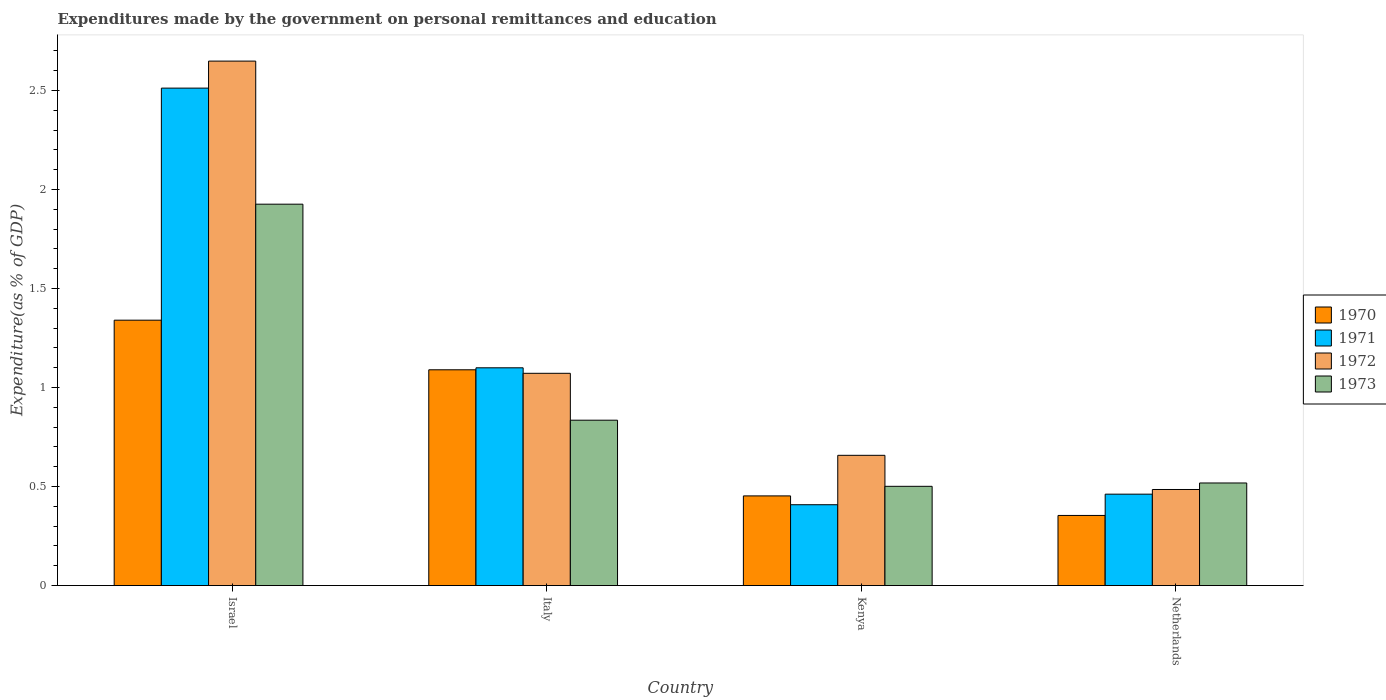How many groups of bars are there?
Make the answer very short. 4. Are the number of bars per tick equal to the number of legend labels?
Your answer should be very brief. Yes. Are the number of bars on each tick of the X-axis equal?
Give a very brief answer. Yes. How many bars are there on the 4th tick from the left?
Ensure brevity in your answer.  4. How many bars are there on the 1st tick from the right?
Make the answer very short. 4. What is the expenditures made by the government on personal remittances and education in 1973 in Netherlands?
Ensure brevity in your answer.  0.52. Across all countries, what is the maximum expenditures made by the government on personal remittances and education in 1973?
Give a very brief answer. 1.93. Across all countries, what is the minimum expenditures made by the government on personal remittances and education in 1970?
Your answer should be compact. 0.35. In which country was the expenditures made by the government on personal remittances and education in 1970 maximum?
Make the answer very short. Israel. What is the total expenditures made by the government on personal remittances and education in 1970 in the graph?
Offer a very short reply. 3.24. What is the difference between the expenditures made by the government on personal remittances and education in 1970 in Israel and that in Kenya?
Your response must be concise. 0.89. What is the difference between the expenditures made by the government on personal remittances and education in 1972 in Israel and the expenditures made by the government on personal remittances and education in 1971 in Netherlands?
Your response must be concise. 2.19. What is the average expenditures made by the government on personal remittances and education in 1971 per country?
Provide a succinct answer. 1.12. What is the difference between the expenditures made by the government on personal remittances and education of/in 1971 and expenditures made by the government on personal remittances and education of/in 1973 in Netherlands?
Provide a short and direct response. -0.06. What is the ratio of the expenditures made by the government on personal remittances and education in 1970 in Italy to that in Kenya?
Your response must be concise. 2.41. What is the difference between the highest and the second highest expenditures made by the government on personal remittances and education in 1972?
Provide a short and direct response. -0.41. What is the difference between the highest and the lowest expenditures made by the government on personal remittances and education in 1973?
Keep it short and to the point. 1.42. In how many countries, is the expenditures made by the government on personal remittances and education in 1970 greater than the average expenditures made by the government on personal remittances and education in 1970 taken over all countries?
Provide a succinct answer. 2. What does the 2nd bar from the left in Israel represents?
Offer a very short reply. 1971. What does the 1st bar from the right in Kenya represents?
Your answer should be compact. 1973. How many bars are there?
Offer a terse response. 16. How many legend labels are there?
Offer a terse response. 4. How are the legend labels stacked?
Provide a short and direct response. Vertical. What is the title of the graph?
Your response must be concise. Expenditures made by the government on personal remittances and education. What is the label or title of the Y-axis?
Keep it short and to the point. Expenditure(as % of GDP). What is the Expenditure(as % of GDP) in 1970 in Israel?
Offer a terse response. 1.34. What is the Expenditure(as % of GDP) of 1971 in Israel?
Your answer should be compact. 2.51. What is the Expenditure(as % of GDP) in 1972 in Israel?
Make the answer very short. 2.65. What is the Expenditure(as % of GDP) in 1973 in Israel?
Provide a succinct answer. 1.93. What is the Expenditure(as % of GDP) in 1970 in Italy?
Your response must be concise. 1.09. What is the Expenditure(as % of GDP) in 1971 in Italy?
Give a very brief answer. 1.1. What is the Expenditure(as % of GDP) in 1972 in Italy?
Offer a terse response. 1.07. What is the Expenditure(as % of GDP) in 1973 in Italy?
Offer a very short reply. 0.84. What is the Expenditure(as % of GDP) in 1970 in Kenya?
Provide a succinct answer. 0.45. What is the Expenditure(as % of GDP) in 1971 in Kenya?
Provide a short and direct response. 0.41. What is the Expenditure(as % of GDP) in 1972 in Kenya?
Keep it short and to the point. 0.66. What is the Expenditure(as % of GDP) in 1973 in Kenya?
Offer a very short reply. 0.5. What is the Expenditure(as % of GDP) of 1970 in Netherlands?
Offer a very short reply. 0.35. What is the Expenditure(as % of GDP) of 1971 in Netherlands?
Offer a very short reply. 0.46. What is the Expenditure(as % of GDP) of 1972 in Netherlands?
Make the answer very short. 0.49. What is the Expenditure(as % of GDP) of 1973 in Netherlands?
Your answer should be very brief. 0.52. Across all countries, what is the maximum Expenditure(as % of GDP) of 1970?
Give a very brief answer. 1.34. Across all countries, what is the maximum Expenditure(as % of GDP) in 1971?
Give a very brief answer. 2.51. Across all countries, what is the maximum Expenditure(as % of GDP) in 1972?
Make the answer very short. 2.65. Across all countries, what is the maximum Expenditure(as % of GDP) in 1973?
Your response must be concise. 1.93. Across all countries, what is the minimum Expenditure(as % of GDP) in 1970?
Offer a terse response. 0.35. Across all countries, what is the minimum Expenditure(as % of GDP) of 1971?
Offer a terse response. 0.41. Across all countries, what is the minimum Expenditure(as % of GDP) in 1972?
Make the answer very short. 0.49. Across all countries, what is the minimum Expenditure(as % of GDP) in 1973?
Give a very brief answer. 0.5. What is the total Expenditure(as % of GDP) in 1970 in the graph?
Your answer should be compact. 3.24. What is the total Expenditure(as % of GDP) in 1971 in the graph?
Offer a very short reply. 4.48. What is the total Expenditure(as % of GDP) of 1972 in the graph?
Ensure brevity in your answer.  4.86. What is the total Expenditure(as % of GDP) in 1973 in the graph?
Ensure brevity in your answer.  3.78. What is the difference between the Expenditure(as % of GDP) in 1970 in Israel and that in Italy?
Ensure brevity in your answer.  0.25. What is the difference between the Expenditure(as % of GDP) in 1971 in Israel and that in Italy?
Offer a very short reply. 1.41. What is the difference between the Expenditure(as % of GDP) of 1972 in Israel and that in Italy?
Give a very brief answer. 1.58. What is the difference between the Expenditure(as % of GDP) in 1970 in Israel and that in Kenya?
Your answer should be compact. 0.89. What is the difference between the Expenditure(as % of GDP) of 1971 in Israel and that in Kenya?
Provide a short and direct response. 2.1. What is the difference between the Expenditure(as % of GDP) in 1972 in Israel and that in Kenya?
Your response must be concise. 1.99. What is the difference between the Expenditure(as % of GDP) of 1973 in Israel and that in Kenya?
Offer a terse response. 1.42. What is the difference between the Expenditure(as % of GDP) of 1970 in Israel and that in Netherlands?
Provide a short and direct response. 0.99. What is the difference between the Expenditure(as % of GDP) of 1971 in Israel and that in Netherlands?
Give a very brief answer. 2.05. What is the difference between the Expenditure(as % of GDP) in 1972 in Israel and that in Netherlands?
Your answer should be very brief. 2.16. What is the difference between the Expenditure(as % of GDP) in 1973 in Israel and that in Netherlands?
Give a very brief answer. 1.41. What is the difference between the Expenditure(as % of GDP) of 1970 in Italy and that in Kenya?
Provide a short and direct response. 0.64. What is the difference between the Expenditure(as % of GDP) in 1971 in Italy and that in Kenya?
Your response must be concise. 0.69. What is the difference between the Expenditure(as % of GDP) in 1972 in Italy and that in Kenya?
Give a very brief answer. 0.41. What is the difference between the Expenditure(as % of GDP) in 1973 in Italy and that in Kenya?
Make the answer very short. 0.33. What is the difference between the Expenditure(as % of GDP) of 1970 in Italy and that in Netherlands?
Your answer should be compact. 0.74. What is the difference between the Expenditure(as % of GDP) of 1971 in Italy and that in Netherlands?
Offer a very short reply. 0.64. What is the difference between the Expenditure(as % of GDP) in 1972 in Italy and that in Netherlands?
Your response must be concise. 0.59. What is the difference between the Expenditure(as % of GDP) in 1973 in Italy and that in Netherlands?
Offer a terse response. 0.32. What is the difference between the Expenditure(as % of GDP) of 1970 in Kenya and that in Netherlands?
Give a very brief answer. 0.1. What is the difference between the Expenditure(as % of GDP) of 1971 in Kenya and that in Netherlands?
Ensure brevity in your answer.  -0.05. What is the difference between the Expenditure(as % of GDP) in 1972 in Kenya and that in Netherlands?
Provide a succinct answer. 0.17. What is the difference between the Expenditure(as % of GDP) in 1973 in Kenya and that in Netherlands?
Keep it short and to the point. -0.02. What is the difference between the Expenditure(as % of GDP) of 1970 in Israel and the Expenditure(as % of GDP) of 1971 in Italy?
Offer a very short reply. 0.24. What is the difference between the Expenditure(as % of GDP) of 1970 in Israel and the Expenditure(as % of GDP) of 1972 in Italy?
Ensure brevity in your answer.  0.27. What is the difference between the Expenditure(as % of GDP) in 1970 in Israel and the Expenditure(as % of GDP) in 1973 in Italy?
Make the answer very short. 0.51. What is the difference between the Expenditure(as % of GDP) in 1971 in Israel and the Expenditure(as % of GDP) in 1972 in Italy?
Give a very brief answer. 1.44. What is the difference between the Expenditure(as % of GDP) of 1971 in Israel and the Expenditure(as % of GDP) of 1973 in Italy?
Your response must be concise. 1.68. What is the difference between the Expenditure(as % of GDP) in 1972 in Israel and the Expenditure(as % of GDP) in 1973 in Italy?
Make the answer very short. 1.81. What is the difference between the Expenditure(as % of GDP) of 1970 in Israel and the Expenditure(as % of GDP) of 1971 in Kenya?
Offer a very short reply. 0.93. What is the difference between the Expenditure(as % of GDP) in 1970 in Israel and the Expenditure(as % of GDP) in 1972 in Kenya?
Offer a very short reply. 0.68. What is the difference between the Expenditure(as % of GDP) of 1970 in Israel and the Expenditure(as % of GDP) of 1973 in Kenya?
Provide a succinct answer. 0.84. What is the difference between the Expenditure(as % of GDP) of 1971 in Israel and the Expenditure(as % of GDP) of 1972 in Kenya?
Make the answer very short. 1.85. What is the difference between the Expenditure(as % of GDP) of 1971 in Israel and the Expenditure(as % of GDP) of 1973 in Kenya?
Your answer should be compact. 2.01. What is the difference between the Expenditure(as % of GDP) of 1972 in Israel and the Expenditure(as % of GDP) of 1973 in Kenya?
Keep it short and to the point. 2.15. What is the difference between the Expenditure(as % of GDP) in 1970 in Israel and the Expenditure(as % of GDP) in 1971 in Netherlands?
Provide a short and direct response. 0.88. What is the difference between the Expenditure(as % of GDP) in 1970 in Israel and the Expenditure(as % of GDP) in 1972 in Netherlands?
Offer a very short reply. 0.85. What is the difference between the Expenditure(as % of GDP) of 1970 in Israel and the Expenditure(as % of GDP) of 1973 in Netherlands?
Provide a short and direct response. 0.82. What is the difference between the Expenditure(as % of GDP) in 1971 in Israel and the Expenditure(as % of GDP) in 1972 in Netherlands?
Keep it short and to the point. 2.03. What is the difference between the Expenditure(as % of GDP) of 1971 in Israel and the Expenditure(as % of GDP) of 1973 in Netherlands?
Provide a short and direct response. 1.99. What is the difference between the Expenditure(as % of GDP) in 1972 in Israel and the Expenditure(as % of GDP) in 1973 in Netherlands?
Ensure brevity in your answer.  2.13. What is the difference between the Expenditure(as % of GDP) of 1970 in Italy and the Expenditure(as % of GDP) of 1971 in Kenya?
Provide a short and direct response. 0.68. What is the difference between the Expenditure(as % of GDP) of 1970 in Italy and the Expenditure(as % of GDP) of 1972 in Kenya?
Provide a succinct answer. 0.43. What is the difference between the Expenditure(as % of GDP) of 1970 in Italy and the Expenditure(as % of GDP) of 1973 in Kenya?
Make the answer very short. 0.59. What is the difference between the Expenditure(as % of GDP) in 1971 in Italy and the Expenditure(as % of GDP) in 1972 in Kenya?
Provide a short and direct response. 0.44. What is the difference between the Expenditure(as % of GDP) of 1971 in Italy and the Expenditure(as % of GDP) of 1973 in Kenya?
Provide a short and direct response. 0.6. What is the difference between the Expenditure(as % of GDP) of 1972 in Italy and the Expenditure(as % of GDP) of 1973 in Kenya?
Ensure brevity in your answer.  0.57. What is the difference between the Expenditure(as % of GDP) in 1970 in Italy and the Expenditure(as % of GDP) in 1971 in Netherlands?
Provide a succinct answer. 0.63. What is the difference between the Expenditure(as % of GDP) in 1970 in Italy and the Expenditure(as % of GDP) in 1972 in Netherlands?
Provide a short and direct response. 0.6. What is the difference between the Expenditure(as % of GDP) in 1970 in Italy and the Expenditure(as % of GDP) in 1973 in Netherlands?
Keep it short and to the point. 0.57. What is the difference between the Expenditure(as % of GDP) of 1971 in Italy and the Expenditure(as % of GDP) of 1972 in Netherlands?
Offer a terse response. 0.61. What is the difference between the Expenditure(as % of GDP) in 1971 in Italy and the Expenditure(as % of GDP) in 1973 in Netherlands?
Offer a very short reply. 0.58. What is the difference between the Expenditure(as % of GDP) of 1972 in Italy and the Expenditure(as % of GDP) of 1973 in Netherlands?
Your response must be concise. 0.55. What is the difference between the Expenditure(as % of GDP) of 1970 in Kenya and the Expenditure(as % of GDP) of 1971 in Netherlands?
Your response must be concise. -0.01. What is the difference between the Expenditure(as % of GDP) in 1970 in Kenya and the Expenditure(as % of GDP) in 1972 in Netherlands?
Your answer should be compact. -0.03. What is the difference between the Expenditure(as % of GDP) of 1970 in Kenya and the Expenditure(as % of GDP) of 1973 in Netherlands?
Provide a succinct answer. -0.07. What is the difference between the Expenditure(as % of GDP) of 1971 in Kenya and the Expenditure(as % of GDP) of 1972 in Netherlands?
Keep it short and to the point. -0.08. What is the difference between the Expenditure(as % of GDP) of 1971 in Kenya and the Expenditure(as % of GDP) of 1973 in Netherlands?
Keep it short and to the point. -0.11. What is the difference between the Expenditure(as % of GDP) in 1972 in Kenya and the Expenditure(as % of GDP) in 1973 in Netherlands?
Give a very brief answer. 0.14. What is the average Expenditure(as % of GDP) of 1970 per country?
Give a very brief answer. 0.81. What is the average Expenditure(as % of GDP) in 1971 per country?
Offer a very short reply. 1.12. What is the average Expenditure(as % of GDP) of 1972 per country?
Provide a short and direct response. 1.22. What is the average Expenditure(as % of GDP) of 1973 per country?
Keep it short and to the point. 0.95. What is the difference between the Expenditure(as % of GDP) in 1970 and Expenditure(as % of GDP) in 1971 in Israel?
Offer a very short reply. -1.17. What is the difference between the Expenditure(as % of GDP) in 1970 and Expenditure(as % of GDP) in 1972 in Israel?
Ensure brevity in your answer.  -1.31. What is the difference between the Expenditure(as % of GDP) of 1970 and Expenditure(as % of GDP) of 1973 in Israel?
Make the answer very short. -0.59. What is the difference between the Expenditure(as % of GDP) in 1971 and Expenditure(as % of GDP) in 1972 in Israel?
Make the answer very short. -0.14. What is the difference between the Expenditure(as % of GDP) in 1971 and Expenditure(as % of GDP) in 1973 in Israel?
Your answer should be compact. 0.59. What is the difference between the Expenditure(as % of GDP) of 1972 and Expenditure(as % of GDP) of 1973 in Israel?
Your response must be concise. 0.72. What is the difference between the Expenditure(as % of GDP) of 1970 and Expenditure(as % of GDP) of 1971 in Italy?
Your response must be concise. -0.01. What is the difference between the Expenditure(as % of GDP) in 1970 and Expenditure(as % of GDP) in 1972 in Italy?
Provide a succinct answer. 0.02. What is the difference between the Expenditure(as % of GDP) in 1970 and Expenditure(as % of GDP) in 1973 in Italy?
Keep it short and to the point. 0.25. What is the difference between the Expenditure(as % of GDP) in 1971 and Expenditure(as % of GDP) in 1972 in Italy?
Your response must be concise. 0.03. What is the difference between the Expenditure(as % of GDP) of 1971 and Expenditure(as % of GDP) of 1973 in Italy?
Your answer should be compact. 0.26. What is the difference between the Expenditure(as % of GDP) of 1972 and Expenditure(as % of GDP) of 1973 in Italy?
Ensure brevity in your answer.  0.24. What is the difference between the Expenditure(as % of GDP) in 1970 and Expenditure(as % of GDP) in 1971 in Kenya?
Your answer should be very brief. 0.04. What is the difference between the Expenditure(as % of GDP) of 1970 and Expenditure(as % of GDP) of 1972 in Kenya?
Make the answer very short. -0.2. What is the difference between the Expenditure(as % of GDP) of 1970 and Expenditure(as % of GDP) of 1973 in Kenya?
Your response must be concise. -0.05. What is the difference between the Expenditure(as % of GDP) of 1971 and Expenditure(as % of GDP) of 1972 in Kenya?
Ensure brevity in your answer.  -0.25. What is the difference between the Expenditure(as % of GDP) in 1971 and Expenditure(as % of GDP) in 1973 in Kenya?
Provide a short and direct response. -0.09. What is the difference between the Expenditure(as % of GDP) in 1972 and Expenditure(as % of GDP) in 1973 in Kenya?
Make the answer very short. 0.16. What is the difference between the Expenditure(as % of GDP) in 1970 and Expenditure(as % of GDP) in 1971 in Netherlands?
Offer a terse response. -0.11. What is the difference between the Expenditure(as % of GDP) in 1970 and Expenditure(as % of GDP) in 1972 in Netherlands?
Your answer should be very brief. -0.13. What is the difference between the Expenditure(as % of GDP) in 1970 and Expenditure(as % of GDP) in 1973 in Netherlands?
Offer a terse response. -0.16. What is the difference between the Expenditure(as % of GDP) of 1971 and Expenditure(as % of GDP) of 1972 in Netherlands?
Your answer should be very brief. -0.02. What is the difference between the Expenditure(as % of GDP) of 1971 and Expenditure(as % of GDP) of 1973 in Netherlands?
Offer a very short reply. -0.06. What is the difference between the Expenditure(as % of GDP) of 1972 and Expenditure(as % of GDP) of 1973 in Netherlands?
Your response must be concise. -0.03. What is the ratio of the Expenditure(as % of GDP) in 1970 in Israel to that in Italy?
Your response must be concise. 1.23. What is the ratio of the Expenditure(as % of GDP) of 1971 in Israel to that in Italy?
Make the answer very short. 2.28. What is the ratio of the Expenditure(as % of GDP) in 1972 in Israel to that in Italy?
Make the answer very short. 2.47. What is the ratio of the Expenditure(as % of GDP) in 1973 in Israel to that in Italy?
Keep it short and to the point. 2.31. What is the ratio of the Expenditure(as % of GDP) in 1970 in Israel to that in Kenya?
Offer a very short reply. 2.96. What is the ratio of the Expenditure(as % of GDP) of 1971 in Israel to that in Kenya?
Your response must be concise. 6.15. What is the ratio of the Expenditure(as % of GDP) of 1972 in Israel to that in Kenya?
Provide a succinct answer. 4.03. What is the ratio of the Expenditure(as % of GDP) of 1973 in Israel to that in Kenya?
Provide a short and direct response. 3.84. What is the ratio of the Expenditure(as % of GDP) of 1970 in Israel to that in Netherlands?
Provide a short and direct response. 3.78. What is the ratio of the Expenditure(as % of GDP) of 1971 in Israel to that in Netherlands?
Ensure brevity in your answer.  5.44. What is the ratio of the Expenditure(as % of GDP) in 1972 in Israel to that in Netherlands?
Provide a short and direct response. 5.46. What is the ratio of the Expenditure(as % of GDP) of 1973 in Israel to that in Netherlands?
Provide a short and direct response. 3.72. What is the ratio of the Expenditure(as % of GDP) in 1970 in Italy to that in Kenya?
Provide a succinct answer. 2.41. What is the ratio of the Expenditure(as % of GDP) in 1971 in Italy to that in Kenya?
Your answer should be compact. 2.69. What is the ratio of the Expenditure(as % of GDP) in 1972 in Italy to that in Kenya?
Your answer should be compact. 1.63. What is the ratio of the Expenditure(as % of GDP) in 1973 in Italy to that in Kenya?
Your answer should be very brief. 1.67. What is the ratio of the Expenditure(as % of GDP) in 1970 in Italy to that in Netherlands?
Make the answer very short. 3.08. What is the ratio of the Expenditure(as % of GDP) of 1971 in Italy to that in Netherlands?
Your answer should be compact. 2.38. What is the ratio of the Expenditure(as % of GDP) in 1972 in Italy to that in Netherlands?
Your answer should be compact. 2.21. What is the ratio of the Expenditure(as % of GDP) of 1973 in Italy to that in Netherlands?
Give a very brief answer. 1.61. What is the ratio of the Expenditure(as % of GDP) of 1970 in Kenya to that in Netherlands?
Offer a very short reply. 1.28. What is the ratio of the Expenditure(as % of GDP) of 1971 in Kenya to that in Netherlands?
Provide a short and direct response. 0.88. What is the ratio of the Expenditure(as % of GDP) in 1972 in Kenya to that in Netherlands?
Offer a terse response. 1.36. What is the ratio of the Expenditure(as % of GDP) of 1973 in Kenya to that in Netherlands?
Make the answer very short. 0.97. What is the difference between the highest and the second highest Expenditure(as % of GDP) in 1970?
Your response must be concise. 0.25. What is the difference between the highest and the second highest Expenditure(as % of GDP) of 1971?
Provide a succinct answer. 1.41. What is the difference between the highest and the second highest Expenditure(as % of GDP) of 1972?
Offer a terse response. 1.58. What is the difference between the highest and the lowest Expenditure(as % of GDP) of 1970?
Your answer should be very brief. 0.99. What is the difference between the highest and the lowest Expenditure(as % of GDP) of 1971?
Keep it short and to the point. 2.1. What is the difference between the highest and the lowest Expenditure(as % of GDP) in 1972?
Give a very brief answer. 2.16. What is the difference between the highest and the lowest Expenditure(as % of GDP) in 1973?
Make the answer very short. 1.42. 